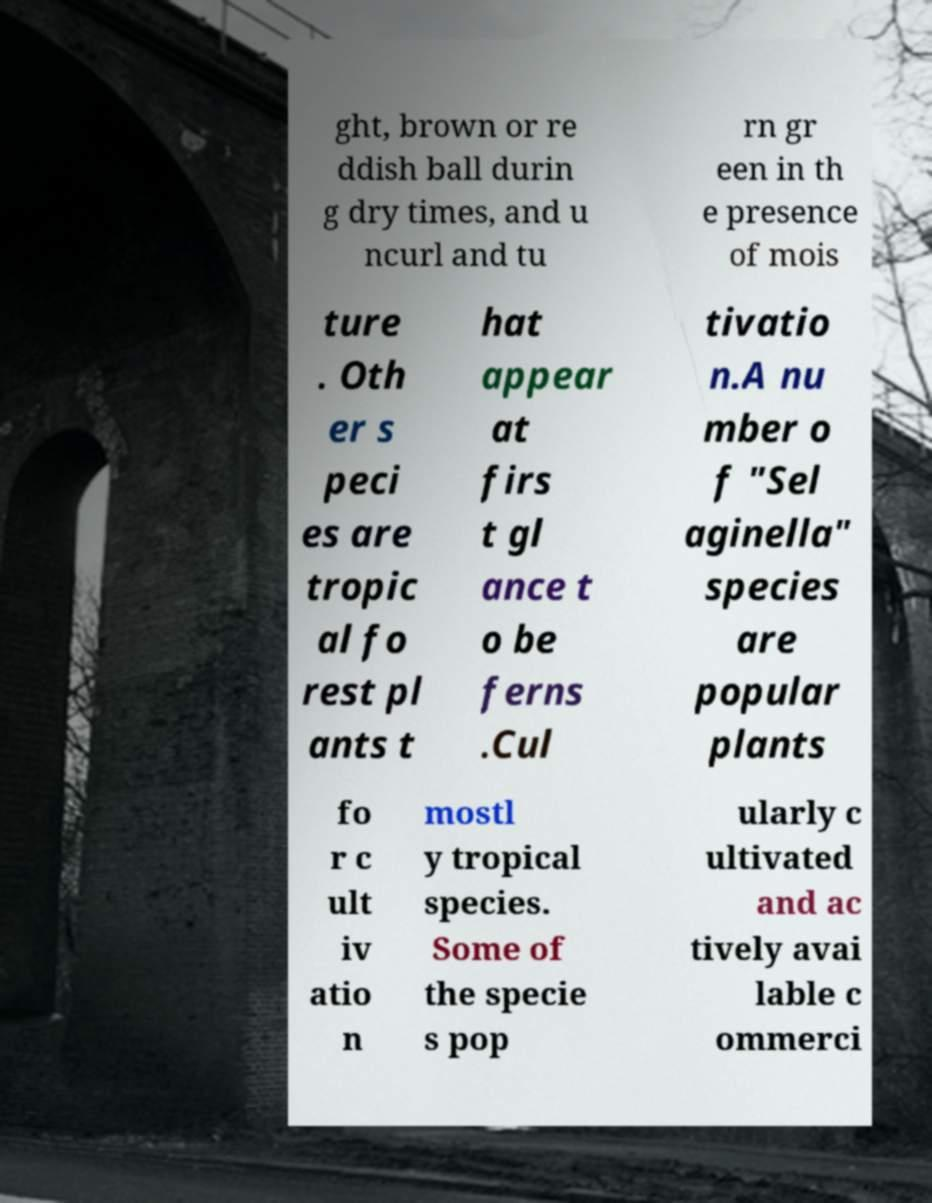Can you read and provide the text displayed in the image?This photo seems to have some interesting text. Can you extract and type it out for me? ght, brown or re ddish ball durin g dry times, and u ncurl and tu rn gr een in th e presence of mois ture . Oth er s peci es are tropic al fo rest pl ants t hat appear at firs t gl ance t o be ferns .Cul tivatio n.A nu mber o f "Sel aginella" species are popular plants fo r c ult iv atio n mostl y tropical species. Some of the specie s pop ularly c ultivated and ac tively avai lable c ommerci 